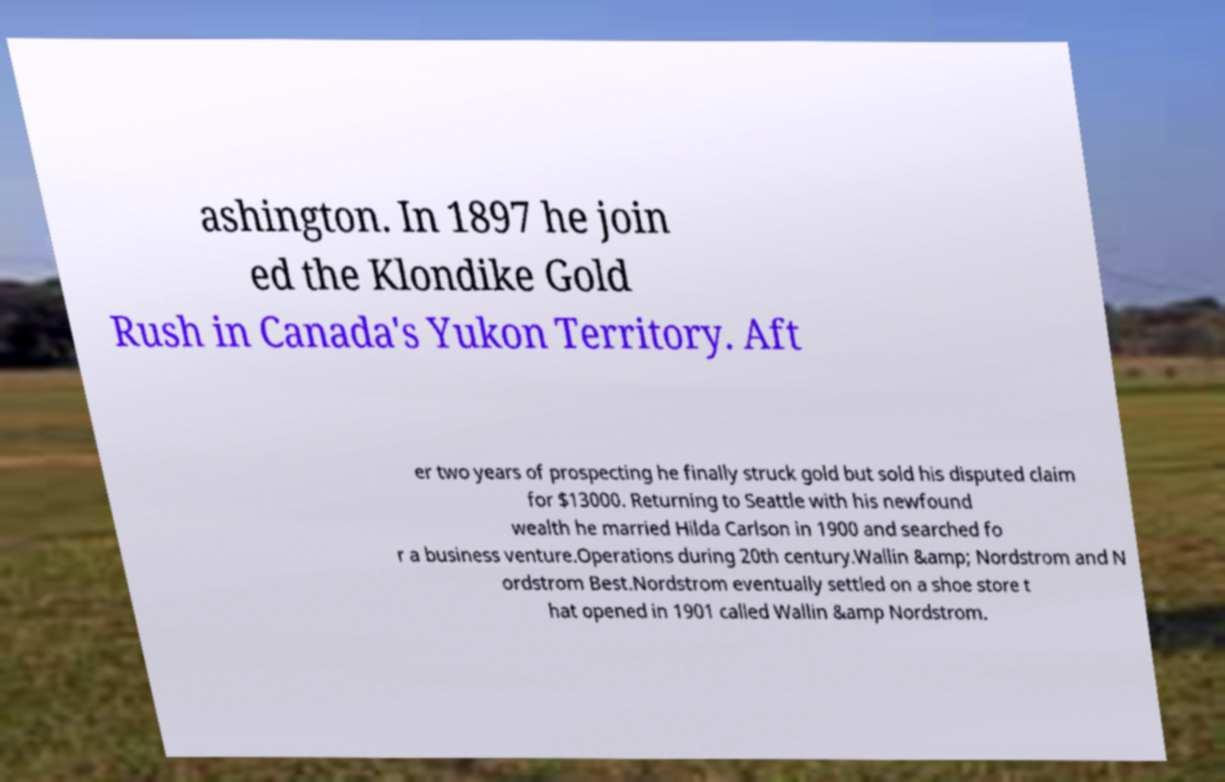Can you read and provide the text displayed in the image?This photo seems to have some interesting text. Can you extract and type it out for me? ashington. In 1897 he join ed the Klondike Gold Rush in Canada's Yukon Territory. Aft er two years of prospecting he finally struck gold but sold his disputed claim for $13000. Returning to Seattle with his newfound wealth he married Hilda Carlson in 1900 and searched fo r a business venture.Operations during 20th century.Wallin &amp; Nordstrom and N ordstrom Best.Nordstrom eventually settled on a shoe store t hat opened in 1901 called Wallin &amp Nordstrom. 